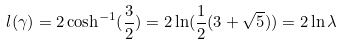<formula> <loc_0><loc_0><loc_500><loc_500>l ( \gamma ) = 2 \cosh ^ { - 1 } ( \frac { 3 } { 2 } ) = 2 \ln ( \frac { 1 } { 2 } ( 3 + \sqrt { 5 } ) ) = 2 \ln \lambda</formula> 